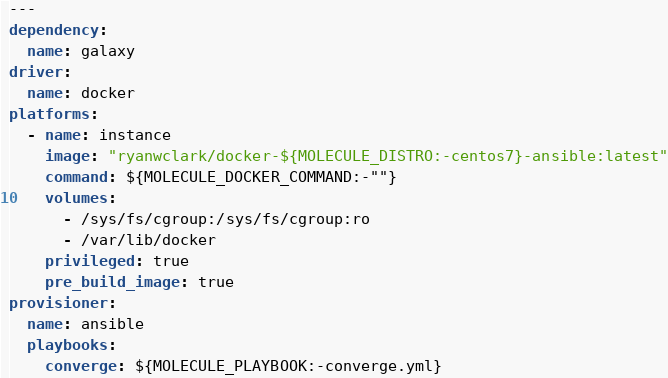Convert code to text. <code><loc_0><loc_0><loc_500><loc_500><_YAML_>---
dependency:
  name: galaxy
driver:
  name: docker
platforms:
  - name: instance
    image: "ryanwclark/docker-${MOLECULE_DISTRO:-centos7}-ansible:latest"
    command: ${MOLECULE_DOCKER_COMMAND:-""}
    volumes:
      - /sys/fs/cgroup:/sys/fs/cgroup:ro
      - /var/lib/docker
    privileged: true
    pre_build_image: true
provisioner:
  name: ansible
  playbooks:
    converge: ${MOLECULE_PLAYBOOK:-converge.yml}
</code> 